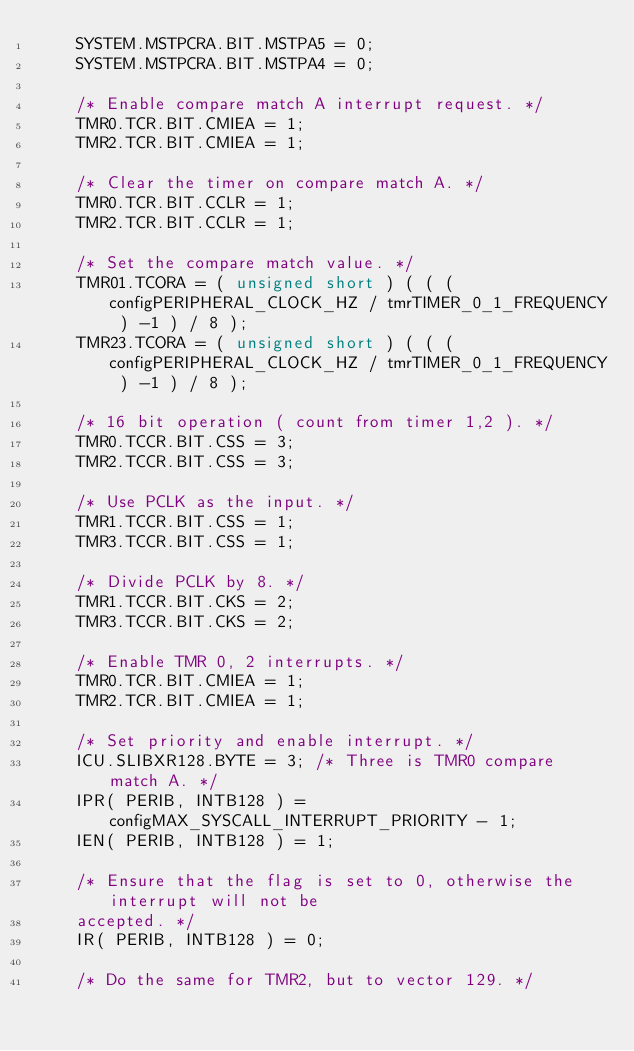<code> <loc_0><loc_0><loc_500><loc_500><_C_>		SYSTEM.MSTPCRA.BIT.MSTPA5 = 0;
		SYSTEM.MSTPCRA.BIT.MSTPA4 = 0;

		/* Enable compare match A interrupt request. */
		TMR0.TCR.BIT.CMIEA = 1;
		TMR2.TCR.BIT.CMIEA = 1;

		/* Clear the timer on compare match A. */
		TMR0.TCR.BIT.CCLR = 1;
		TMR2.TCR.BIT.CCLR = 1;

		/* Set the compare match value. */
		TMR01.TCORA = ( unsigned short ) ( ( ( configPERIPHERAL_CLOCK_HZ / tmrTIMER_0_1_FREQUENCY ) -1 ) / 8 );
		TMR23.TCORA = ( unsigned short ) ( ( ( configPERIPHERAL_CLOCK_HZ / tmrTIMER_0_1_FREQUENCY ) -1 ) / 8 );

		/* 16 bit operation ( count from timer 1,2 ). */
		TMR0.TCCR.BIT.CSS = 3;
		TMR2.TCCR.BIT.CSS = 3;
	
		/* Use PCLK as the input. */
		TMR1.TCCR.BIT.CSS = 1;
		TMR3.TCCR.BIT.CSS = 1;
	
		/* Divide PCLK by 8. */
		TMR1.TCCR.BIT.CKS = 2;
		TMR3.TCCR.BIT.CKS = 2;

		/* Enable TMR 0, 2 interrupts. */
		TMR0.TCR.BIT.CMIEA = 1;
		TMR2.TCR.BIT.CMIEA = 1;

		/* Set priority and enable interrupt. */
		ICU.SLIBXR128.BYTE = 3; /* Three is TMR0 compare match A. */
		IPR( PERIB, INTB128 ) = configMAX_SYSCALL_INTERRUPT_PRIORITY - 1;
		IEN( PERIB, INTB128 ) = 1;

		/* Ensure that the flag is set to 0, otherwise the interrupt will not be
		accepted. */
		IR( PERIB, INTB128 ) = 0;

		/* Do the same for TMR2, but to vector 129. */</code> 